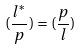Convert formula to latex. <formula><loc_0><loc_0><loc_500><loc_500>( \frac { l ^ { * } } { p } ) = ( \frac { p } { l } )</formula> 